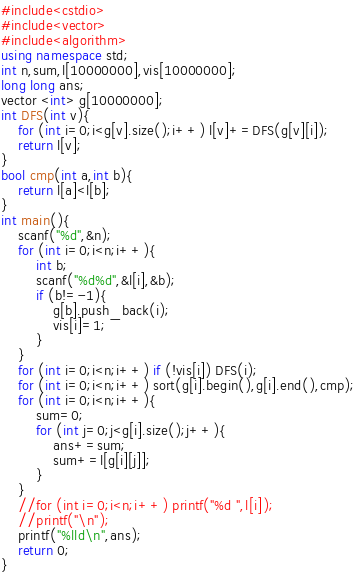Convert code to text. <code><loc_0><loc_0><loc_500><loc_500><_C++_>#include<cstdio>
#include<vector>
#include<algorithm>
using namespace std;
int n,sum,l[10000000],vis[10000000];
long long ans;
vector <int> g[10000000];
int DFS(int v){
	for (int i=0;i<g[v].size();i++) l[v]+=DFS(g[v][i]);
	return l[v];
}
bool cmp(int a,int b){
	return l[a]<l[b];
}
int main(){
	scanf("%d",&n);
	for (int i=0;i<n;i++){
		int b;
		scanf("%d%d",&l[i],&b);
		if (b!=-1){
			g[b].push_back(i);
			vis[i]=1;
		}
	}
	for (int i=0;i<n;i++) if (!vis[i]) DFS(i);
	for (int i=0;i<n;i++) sort(g[i].begin(),g[i].end(),cmp);
	for (int i=0;i<n;i++){
		sum=0;
		for (int j=0;j<g[i].size();j++){
			ans+=sum;
			sum+=l[g[i][j]];
		}
	}
	//for (int i=0;i<n;i++) printf("%d ",l[i]);
	//printf("\n");
	printf("%lld\n",ans);
	return 0;
}</code> 